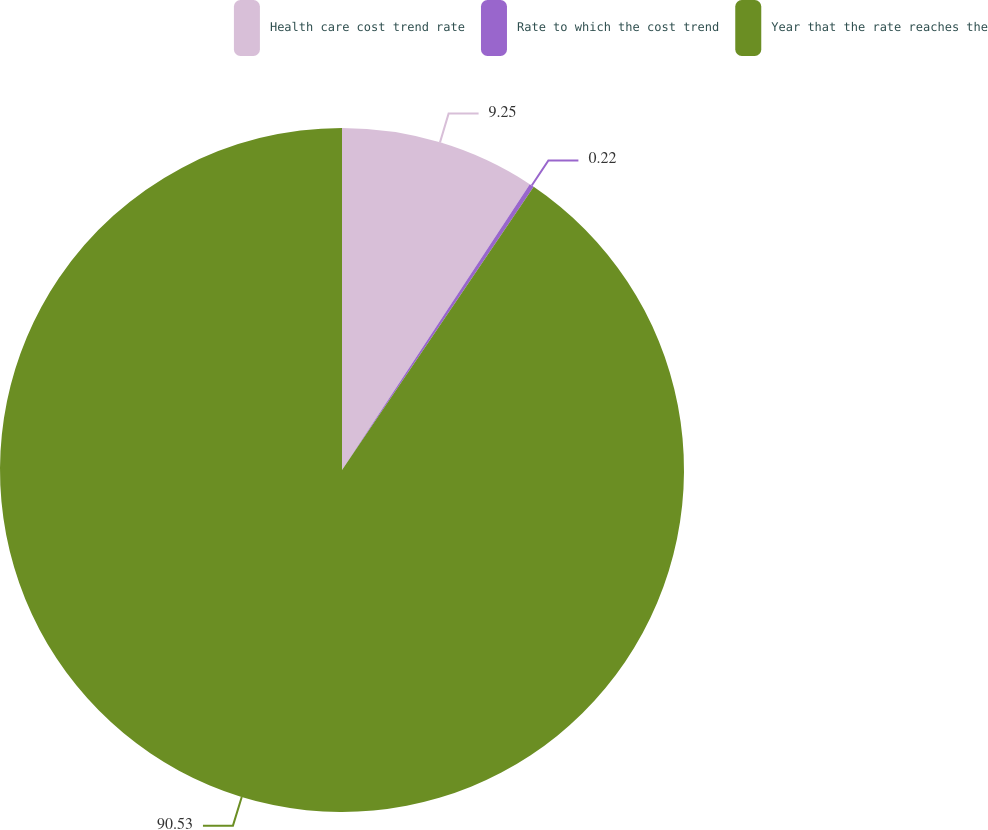Convert chart to OTSL. <chart><loc_0><loc_0><loc_500><loc_500><pie_chart><fcel>Health care cost trend rate<fcel>Rate to which the cost trend<fcel>Year that the rate reaches the<nl><fcel>9.25%<fcel>0.22%<fcel>90.52%<nl></chart> 